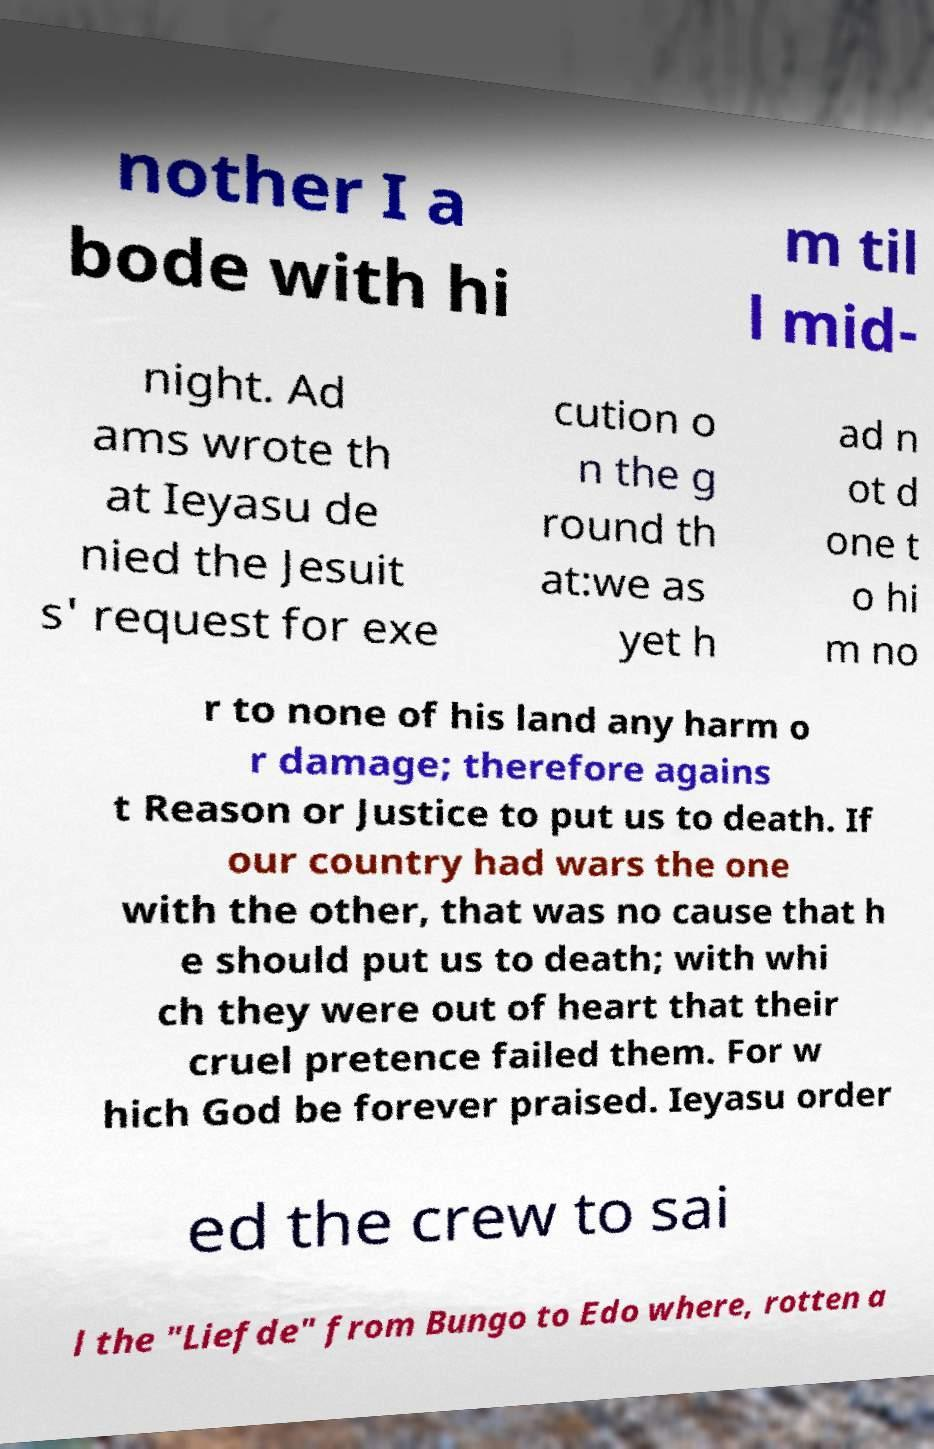What messages or text are displayed in this image? I need them in a readable, typed format. nother I a bode with hi m til l mid- night. Ad ams wrote th at Ieyasu de nied the Jesuit s' request for exe cution o n the g round th at:we as yet h ad n ot d one t o hi m no r to none of his land any harm o r damage; therefore agains t Reason or Justice to put us to death. If our country had wars the one with the other, that was no cause that h e should put us to death; with whi ch they were out of heart that their cruel pretence failed them. For w hich God be forever praised. Ieyasu order ed the crew to sai l the "Liefde" from Bungo to Edo where, rotten a 